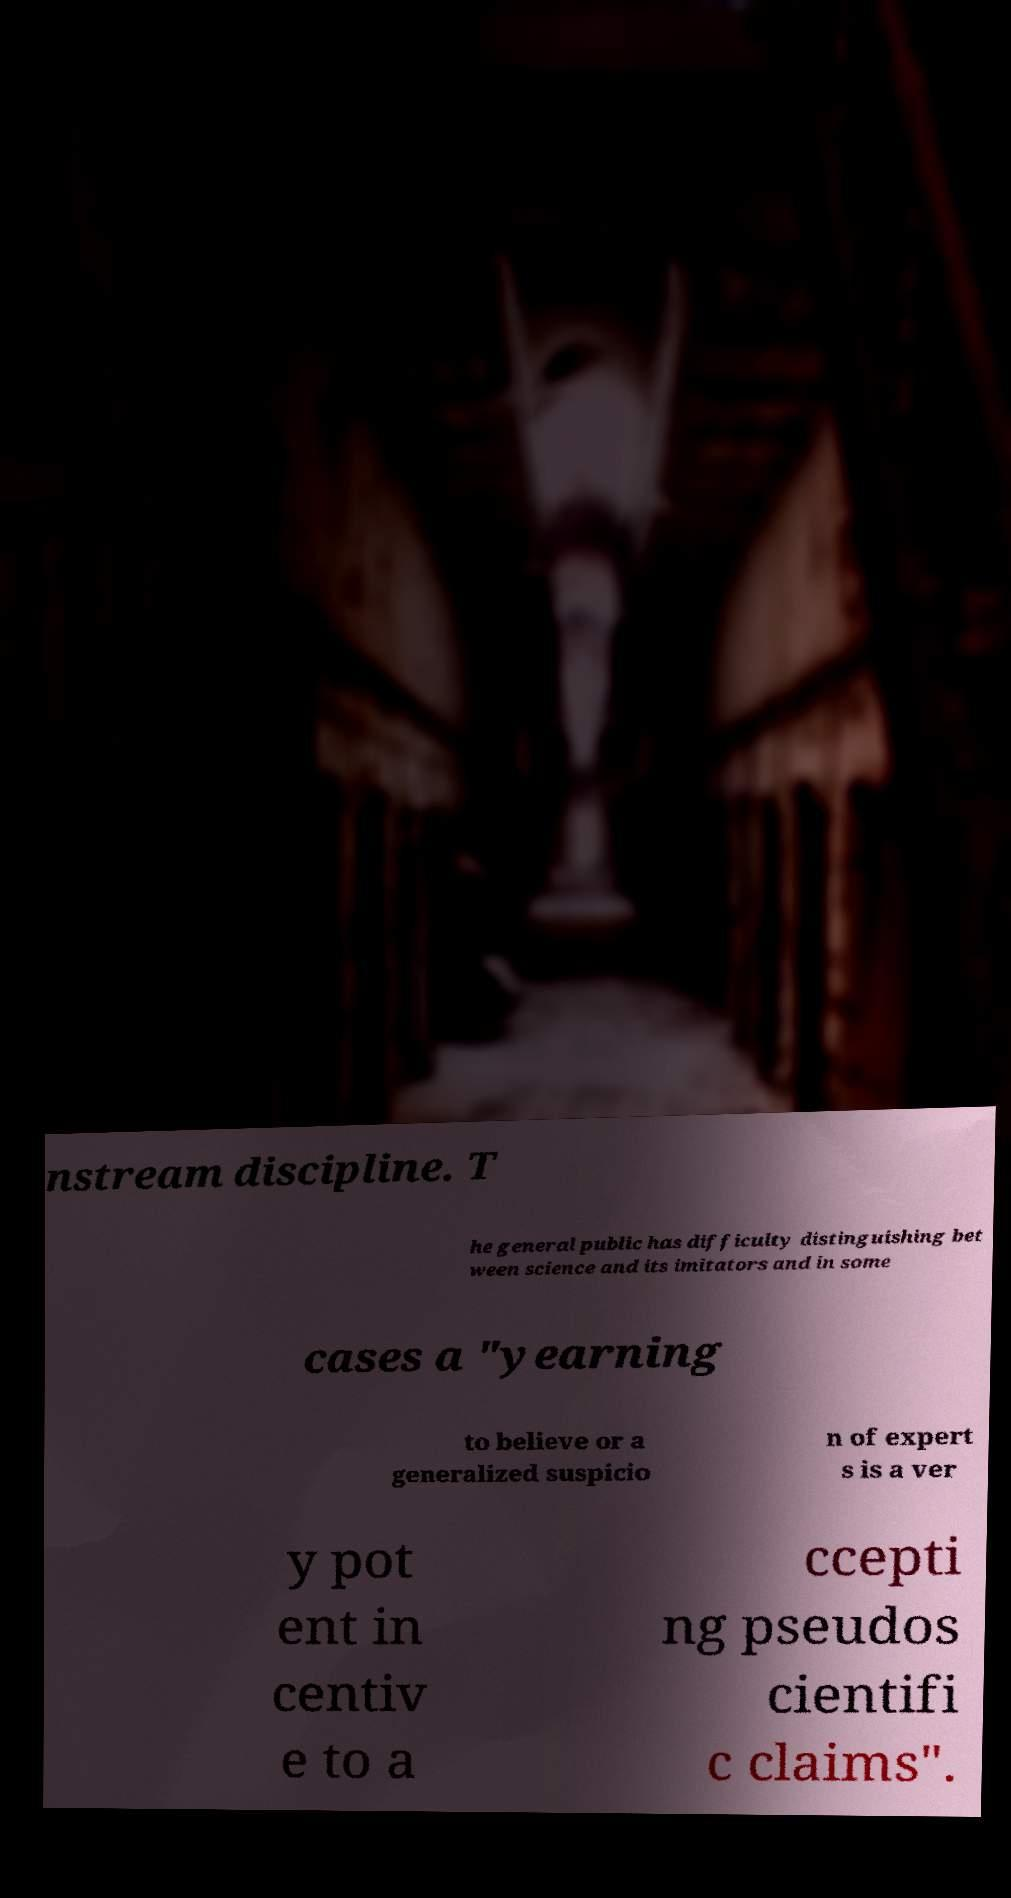For documentation purposes, I need the text within this image transcribed. Could you provide that? nstream discipline. T he general public has difficulty distinguishing bet ween science and its imitators and in some cases a "yearning to believe or a generalized suspicio n of expert s is a ver y pot ent in centiv e to a ccepti ng pseudos cientifi c claims". 